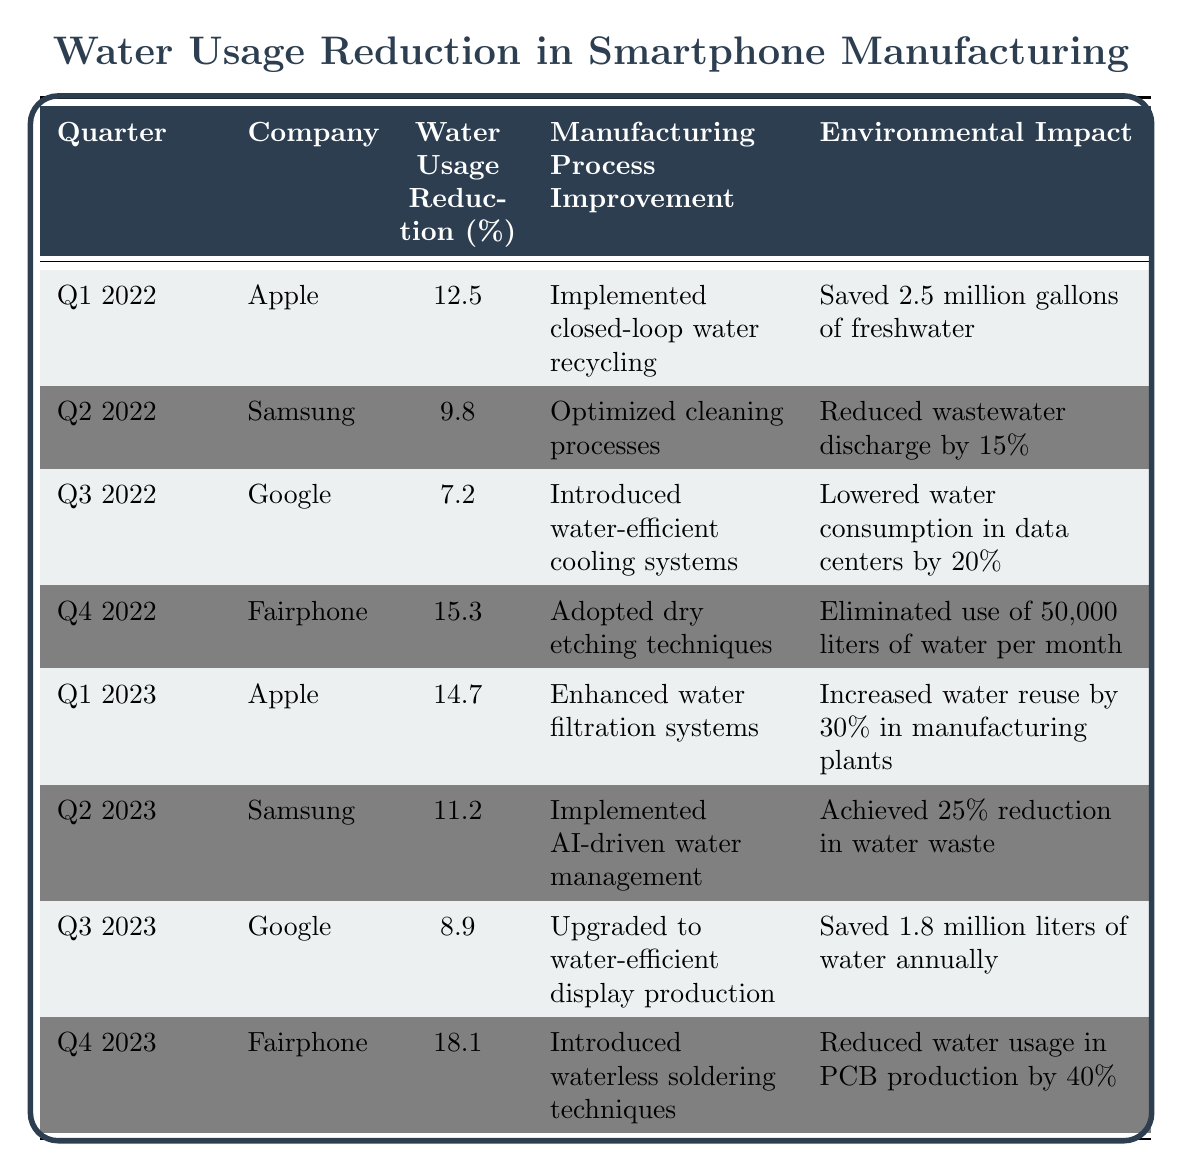What was the highest water usage reduction achieved by Fairphone? In the table, for Q4 2023, Fairphone shows a water usage reduction of 18.1%, which is the highest percentage listed.
Answer: 18.1% Which company reduced its water usage by more than 15% in Q4 2022? The table states that Fairphone achieved a water usage reduction of 15.3% in Q4 2022, which exceeds 15%.
Answer: Yes What is the average water usage reduction for Apple over the two years? To find the average, sum Apple's reductions: 12.5% (Q1 2022) + 14.7% (Q1 2023) = 27.2%. Then divide by 2 for the average: 27.2% / 2 = 13.6%.
Answer: 13.6% Did Google achieve a higher water usage reduction than Samsung in Q2 2023? In Q2 2023, Google had an 8.9% reduction, while Samsung had an 11.2% reduction. Since 11.2% is greater than 8.9%, Google did not achieve a higher reduction.
Answer: No Which quarter had the lowest overall water usage reduction, and what was the percentage? By examining the table, Q3 2022 had the lowest reduction at 7.2%.
Answer: Q3 2022, 7.2% If we sum the water usage reductions for all quarters in 2023, what will be the total? The total reduction for 2023 is: 14.7% (Q1) + 11.2% (Q2) + 8.9% (Q3) + 18.1% (Q4) = 52.9%.
Answer: 52.9% Which company reported the most significant manufacturing process improvement in Q4 2023? The table shows that Fairphone introduced waterless soldering techniques in Q4 2023, which is labeled as a significant improvement.
Answer: Fairphone Was the water usage reduction percentage for Samsung in Q2 2022 higher or lower than that of Google in Q3 2022? Samsung had a reduction of 9.8% in Q2 2022 and Google had 7.2% in Q3 2022. Since 9.8% is greater than 7.2%, Samsung's reduction was higher.
Answer: Higher What is the difference in water usage reduction between the best (highest) and the worst (lowest) performing companies in 2022? The highest performance in 2022 was Fairphone at 15.3% and the lowest was Google at 7.2%. The difference is 15.3% - 7.2% = 8.1%.
Answer: 8.1% Which company consistently improved its water usage reduction from Q1 2022 to Q1 2023? Apple showed an increase from 12.5% in Q1 2022 to 14.7% in Q1 2023, indicating a consistent improvement.
Answer: Apple 